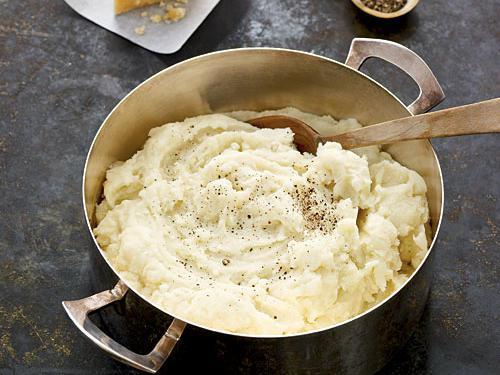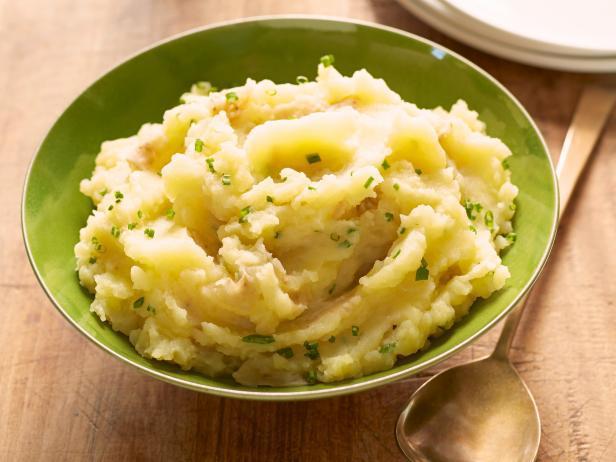The first image is the image on the left, the second image is the image on the right. Analyze the images presented: Is the assertion "The right image contains mashed potatoes in a green bowl." valid? Answer yes or no. Yes. 